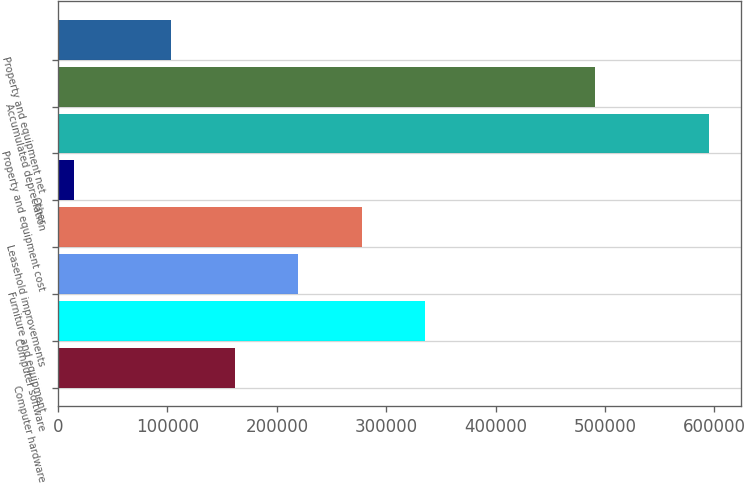<chart> <loc_0><loc_0><loc_500><loc_500><bar_chart><fcel>Computer hardware<fcel>Computer software<fcel>Furniture and equipment<fcel>Leasehold improvements<fcel>Other<fcel>Property and equipment cost<fcel>Accumulated depreciation<fcel>Property and equipment net<nl><fcel>161666<fcel>335709<fcel>219680<fcel>277695<fcel>14716<fcel>594862<fcel>491211<fcel>103651<nl></chart> 